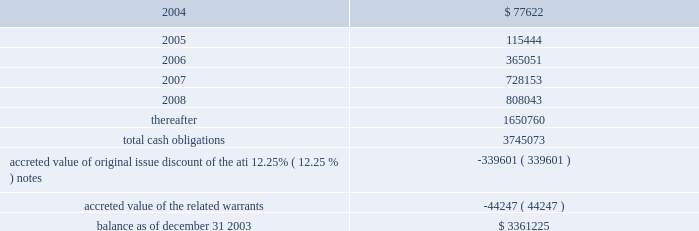American tower corporation and subsidiaries notes to consolidated financial statements 2014 ( continued ) maturities 2014as of december 31 , 2003 , aggregate principal payments of long-term debt , including capital leases , for the next five years and thereafter are estimated to be ( in thousands ) : year ending december 31 .
The holders of the company 2019s convertible notes have the right to require the company to repurchase their notes on specified dates prior to their maturity dates in 2009 and 2010 , but the company may pay the purchase price by issuing shares of class a common stock , subject to certain conditions .
Obligations with respect to the right of the holders to put the 6.25% ( 6.25 % ) notes and 5.0% ( 5.0 % ) notes have been included in the table above as if such notes mature on the date of their put rights in 2006 and 2007 , respectively .
( see note 19. ) 8 .
Derivative financial instruments under the terms of the credit facilities , the company is required to enter into interest rate protection agreements on at least 50% ( 50 % ) of its variable rate debt .
Under these agreements , the company is exposed to credit risk to the extent that a counterparty fails to meet the terms of a contract .
Such exposure is limited to the current value of the contract at the time the counterparty fails to perform .
The company believes its contracts as of december 31 , 2003 are with credit worthy institutions .
As of december 31 , 2003 , the company had three interest rate caps outstanding that include an aggregate notional amount of $ 500.0 million ( each at an interest rate of 5% ( 5 % ) ) and expire in 2004 .
As of december 31 , 2003 and 2002 , liabilities related to derivative financial instruments of $ 0.0 million and $ 15.5 million are reflected in other long-term liabilities in the accompanying consolidated balance sheet .
During the year ended december 31 , 2003 , the company recorded an unrealized loss of approximately $ 0.3 million ( net of a tax benefit of approximately $ 0.2 million ) in other comprehensive loss for the change in fair value of cash flow hedges and reclassified $ 5.9 million ( net of a tax benefit of approximately $ 3.2 million ) into results of operations .
During the year ended december 31 , 2002 , the company recorded an unrealized loss of approximately $ 9.1 million ( net of a tax benefit of approximately $ 4.9 million ) in other comprehensive loss for the change in fair value of cash flow hedges and reclassified $ 19.5 million ( net of a tax benefit of approximately $ 10.5 million ) into results of operations .
Hedge ineffectiveness resulted in a gain of approximately $ 1.0 million and a loss of approximately $ 2.2 million for the years ended december 31 , 2002 and 2001 , respectively , which are recorded in loss on investments and other expense in the accompanying consolidated statements of operations for those periods .
The company records the changes in fair value of its derivative instruments that are not accounted for as hedges in loss on investments and other expense .
The company does not anticipate reclassifying any derivative losses into its statement of operations within the next twelve months , as there are no amounts included in other comprehensive loss as of december 31 , 2003. .
As of december 31 , 2003 , what was the percent of the total cash obligations for aggregate principal payments of long-term debt maturities was due in 2005? 
Computations: (115444 / 3361225)
Answer: 0.03435. 